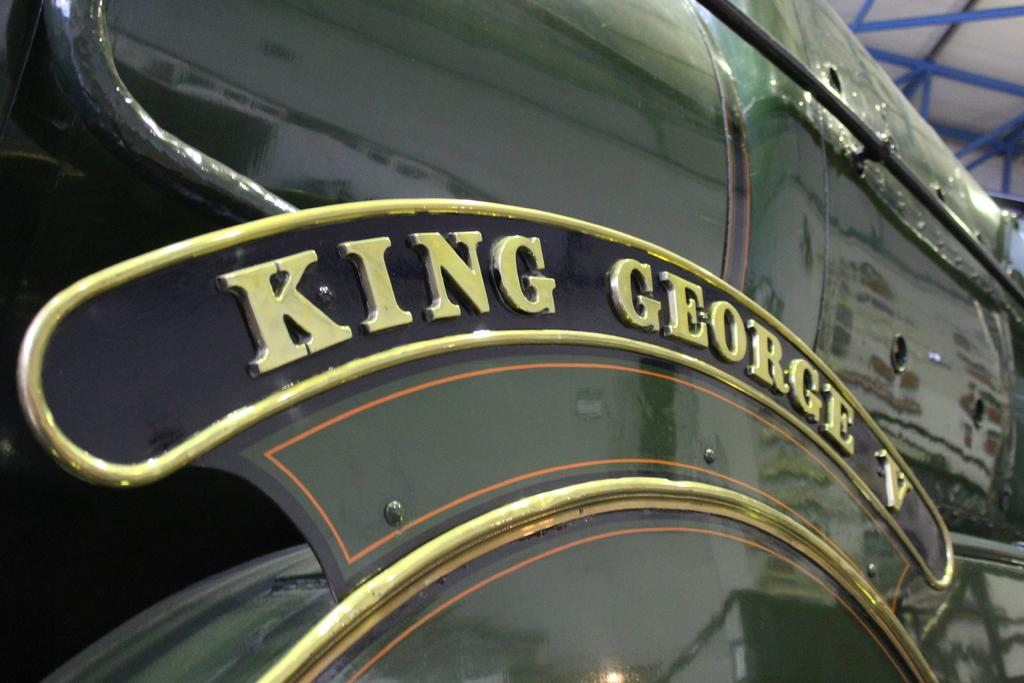What type of object is in the image? There is a vehicle in the image. What color is the vehicle? The vehicle is green in color. Are there any words or names written on the vehicle? Yes, the name "King George" is written on the vehicle. What can be seen in the background of the image? There is a roof visible in the back of the image. How many beginner snails can be seen crawling on the roof in the image? There are no snails, beginner or otherwise, visible on the roof in the image. 